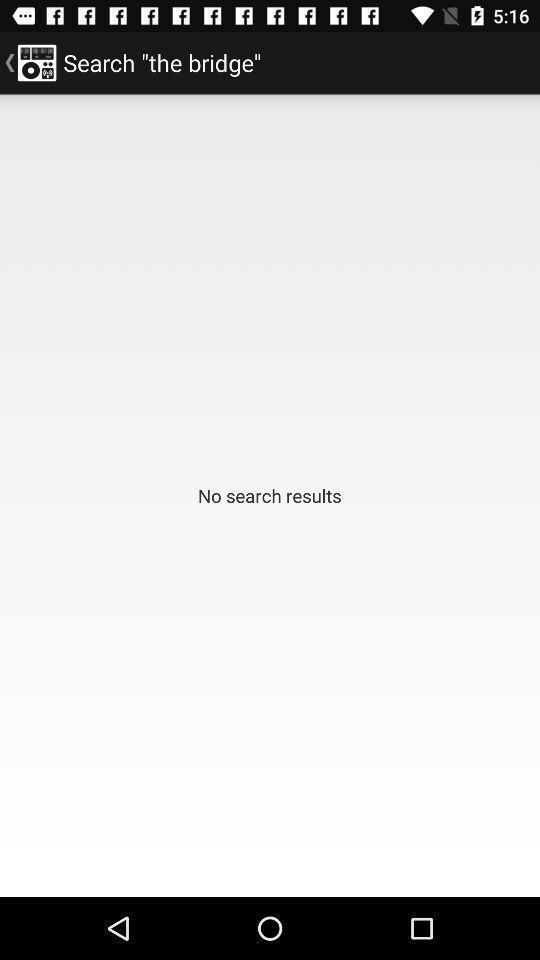Describe the content in this image. Screen asking to search the bridge. 